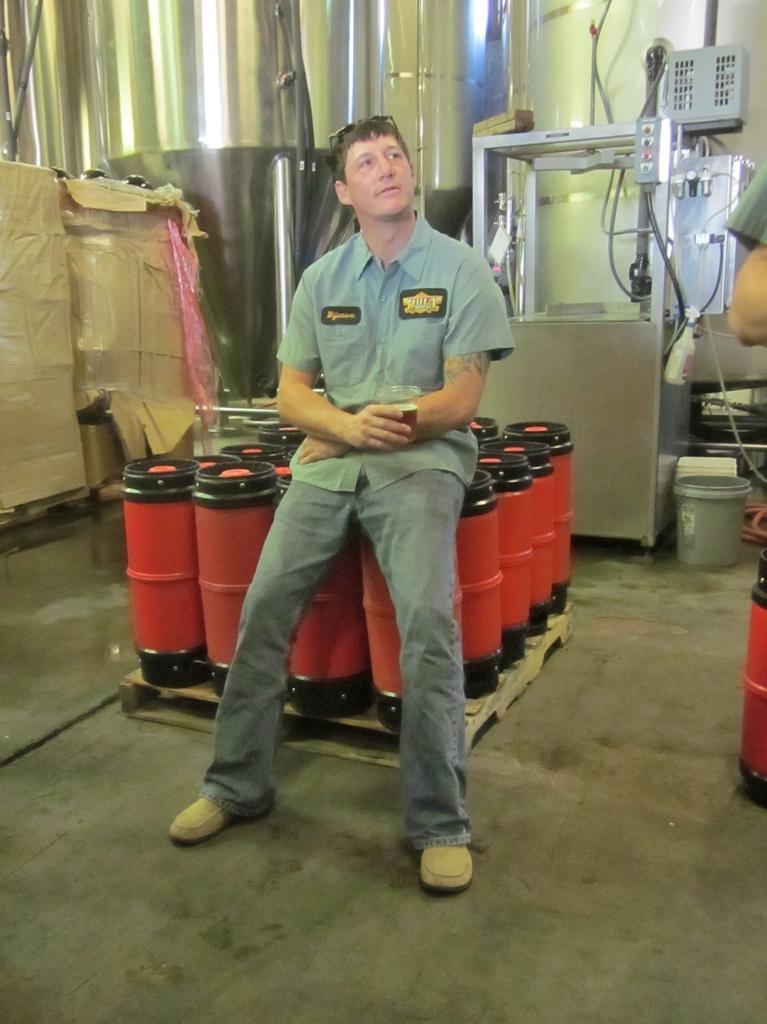Please provide a concise description of this image. In the center of the image we can see a man sitting on the drum kit. On the left there are boxes. In the background there is a wall and we can see some equipment. 